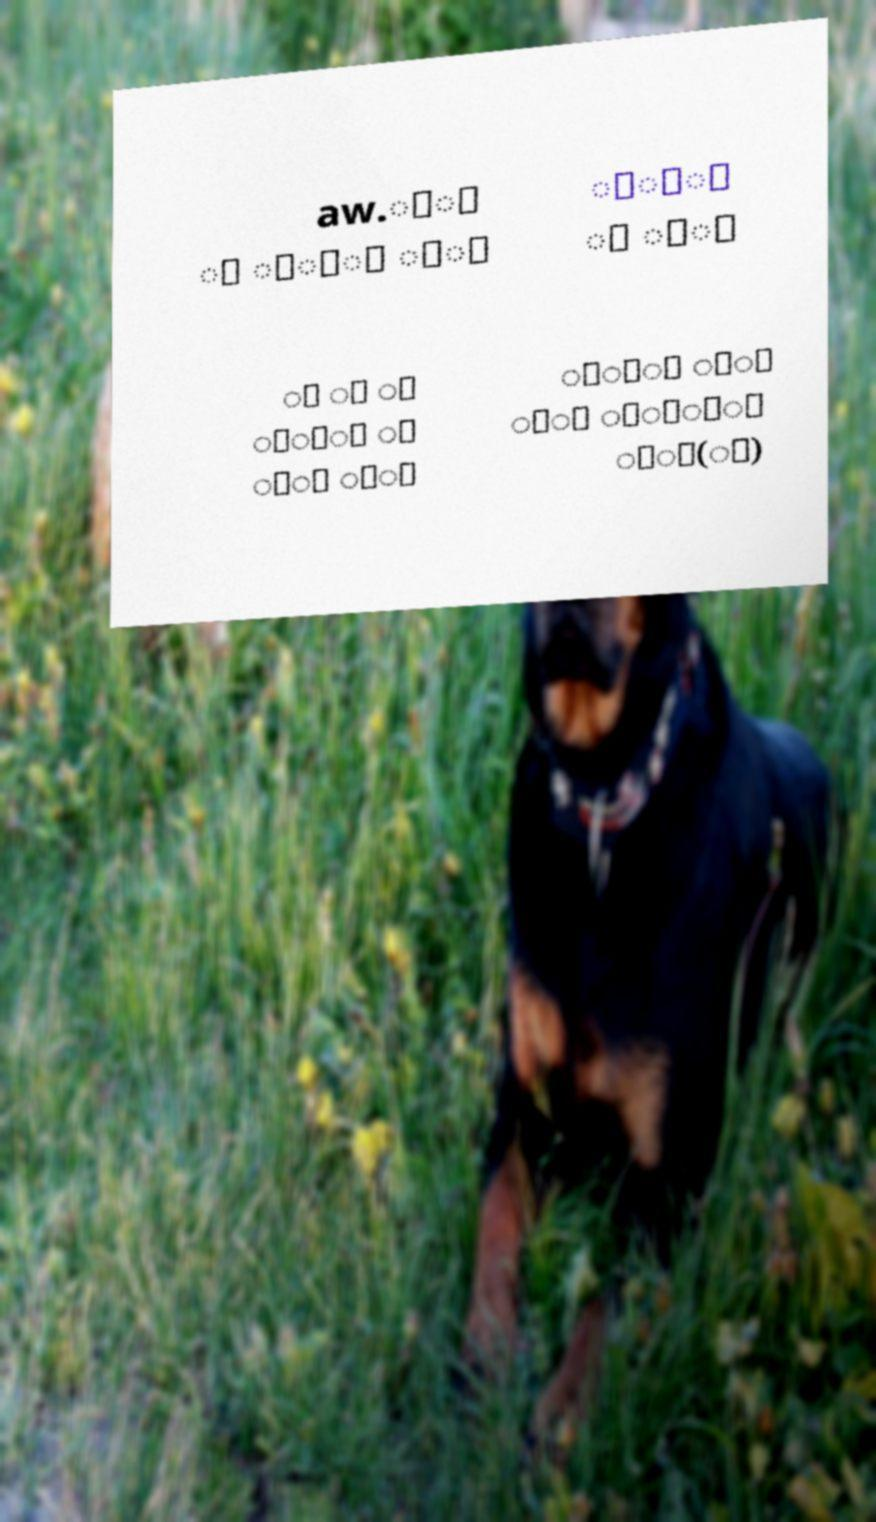Please read and relay the text visible in this image. What does it say? aw.ீ் ் ெ்ா ை் ூ்ா ் ி் ு ை ா ொ்ை ா ு் ூ் ுி் ைு ்் ு்ி் ்்(ு) 